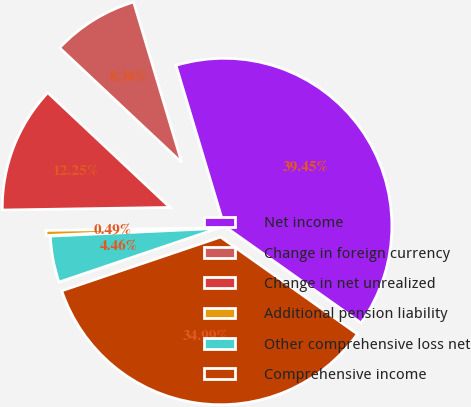Convert chart. <chart><loc_0><loc_0><loc_500><loc_500><pie_chart><fcel>Net income<fcel>Change in foreign currency<fcel>Change in net unrealized<fcel>Additional pension liability<fcel>Other comprehensive loss net<fcel>Comprehensive income<nl><fcel>39.45%<fcel>8.36%<fcel>12.25%<fcel>0.49%<fcel>4.46%<fcel>34.99%<nl></chart> 